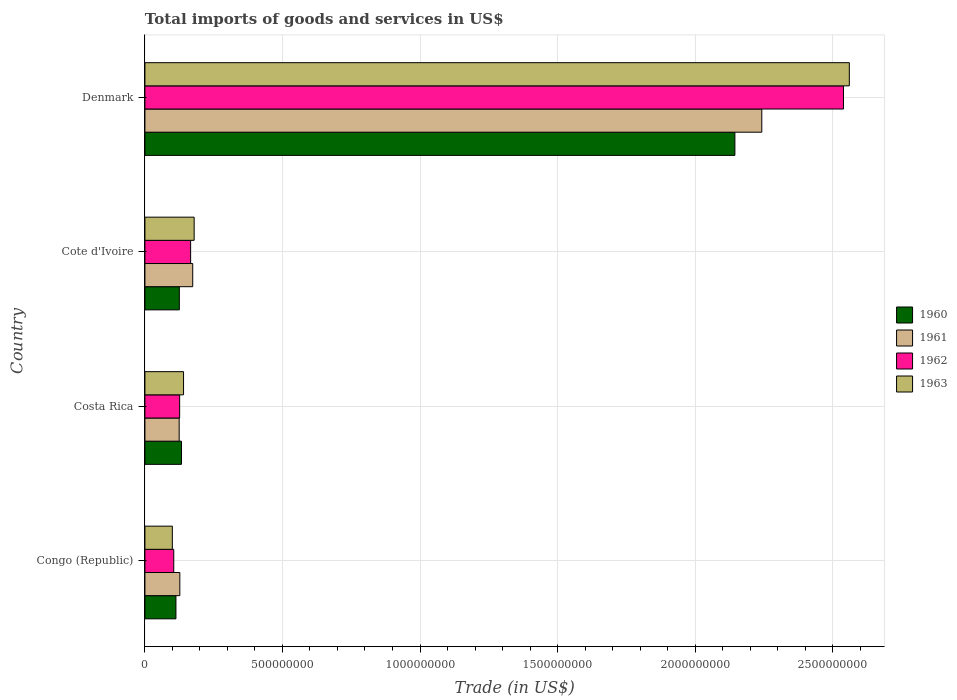How many different coloured bars are there?
Offer a very short reply. 4. How many bars are there on the 4th tick from the top?
Provide a short and direct response. 4. How many bars are there on the 3rd tick from the bottom?
Provide a succinct answer. 4. What is the label of the 2nd group of bars from the top?
Provide a short and direct response. Cote d'Ivoire. In how many cases, is the number of bars for a given country not equal to the number of legend labels?
Give a very brief answer. 0. What is the total imports of goods and services in 1962 in Costa Rica?
Your answer should be very brief. 1.26e+08. Across all countries, what is the maximum total imports of goods and services in 1963?
Your answer should be compact. 2.56e+09. Across all countries, what is the minimum total imports of goods and services in 1960?
Make the answer very short. 1.13e+08. In which country was the total imports of goods and services in 1962 minimum?
Your answer should be compact. Congo (Republic). What is the total total imports of goods and services in 1960 in the graph?
Provide a short and direct response. 2.52e+09. What is the difference between the total imports of goods and services in 1961 in Costa Rica and that in Denmark?
Provide a short and direct response. -2.12e+09. What is the difference between the total imports of goods and services in 1963 in Cote d'Ivoire and the total imports of goods and services in 1960 in Denmark?
Offer a terse response. -1.97e+09. What is the average total imports of goods and services in 1962 per country?
Give a very brief answer. 7.34e+08. What is the difference between the total imports of goods and services in 1963 and total imports of goods and services in 1962 in Congo (Republic)?
Make the answer very short. -5.20e+06. What is the ratio of the total imports of goods and services in 1961 in Costa Rica to that in Denmark?
Your response must be concise. 0.06. Is the total imports of goods and services in 1961 in Costa Rica less than that in Cote d'Ivoire?
Offer a terse response. Yes. Is the difference between the total imports of goods and services in 1963 in Costa Rica and Cote d'Ivoire greater than the difference between the total imports of goods and services in 1962 in Costa Rica and Cote d'Ivoire?
Offer a terse response. Yes. What is the difference between the highest and the second highest total imports of goods and services in 1960?
Make the answer very short. 2.01e+09. What is the difference between the highest and the lowest total imports of goods and services in 1963?
Provide a succinct answer. 2.46e+09. What does the 3rd bar from the top in Denmark represents?
Your answer should be very brief. 1961. What does the 4th bar from the bottom in Cote d'Ivoire represents?
Keep it short and to the point. 1963. How many countries are there in the graph?
Offer a very short reply. 4. What is the difference between two consecutive major ticks on the X-axis?
Offer a very short reply. 5.00e+08. Are the values on the major ticks of X-axis written in scientific E-notation?
Make the answer very short. No. Where does the legend appear in the graph?
Ensure brevity in your answer.  Center right. What is the title of the graph?
Provide a short and direct response. Total imports of goods and services in US$. What is the label or title of the X-axis?
Provide a succinct answer. Trade (in US$). What is the Trade (in US$) in 1960 in Congo (Republic)?
Offer a terse response. 1.13e+08. What is the Trade (in US$) of 1961 in Congo (Republic)?
Provide a short and direct response. 1.27e+08. What is the Trade (in US$) in 1962 in Congo (Republic)?
Offer a terse response. 1.05e+08. What is the Trade (in US$) in 1963 in Congo (Republic)?
Your response must be concise. 9.96e+07. What is the Trade (in US$) of 1960 in Costa Rica?
Provide a succinct answer. 1.33e+08. What is the Trade (in US$) in 1961 in Costa Rica?
Ensure brevity in your answer.  1.25e+08. What is the Trade (in US$) in 1962 in Costa Rica?
Provide a short and direct response. 1.26e+08. What is the Trade (in US$) of 1963 in Costa Rica?
Provide a succinct answer. 1.40e+08. What is the Trade (in US$) in 1960 in Cote d'Ivoire?
Provide a short and direct response. 1.25e+08. What is the Trade (in US$) in 1961 in Cote d'Ivoire?
Ensure brevity in your answer.  1.74e+08. What is the Trade (in US$) in 1962 in Cote d'Ivoire?
Your answer should be compact. 1.66e+08. What is the Trade (in US$) of 1963 in Cote d'Ivoire?
Your answer should be very brief. 1.79e+08. What is the Trade (in US$) in 1960 in Denmark?
Offer a very short reply. 2.14e+09. What is the Trade (in US$) of 1961 in Denmark?
Give a very brief answer. 2.24e+09. What is the Trade (in US$) of 1962 in Denmark?
Offer a very short reply. 2.54e+09. What is the Trade (in US$) of 1963 in Denmark?
Make the answer very short. 2.56e+09. Across all countries, what is the maximum Trade (in US$) in 1960?
Your response must be concise. 2.14e+09. Across all countries, what is the maximum Trade (in US$) of 1961?
Keep it short and to the point. 2.24e+09. Across all countries, what is the maximum Trade (in US$) in 1962?
Provide a succinct answer. 2.54e+09. Across all countries, what is the maximum Trade (in US$) in 1963?
Provide a short and direct response. 2.56e+09. Across all countries, what is the minimum Trade (in US$) of 1960?
Give a very brief answer. 1.13e+08. Across all countries, what is the minimum Trade (in US$) of 1961?
Your answer should be very brief. 1.25e+08. Across all countries, what is the minimum Trade (in US$) in 1962?
Your response must be concise. 1.05e+08. Across all countries, what is the minimum Trade (in US$) of 1963?
Provide a short and direct response. 9.96e+07. What is the total Trade (in US$) in 1960 in the graph?
Offer a very short reply. 2.52e+09. What is the total Trade (in US$) of 1961 in the graph?
Your answer should be very brief. 2.67e+09. What is the total Trade (in US$) in 1962 in the graph?
Make the answer very short. 2.94e+09. What is the total Trade (in US$) in 1963 in the graph?
Provide a succinct answer. 2.98e+09. What is the difference between the Trade (in US$) in 1960 in Congo (Republic) and that in Costa Rica?
Your answer should be compact. -2.01e+07. What is the difference between the Trade (in US$) in 1961 in Congo (Republic) and that in Costa Rica?
Provide a succinct answer. 2.36e+06. What is the difference between the Trade (in US$) of 1962 in Congo (Republic) and that in Costa Rica?
Make the answer very short. -2.14e+07. What is the difference between the Trade (in US$) in 1963 in Congo (Republic) and that in Costa Rica?
Provide a short and direct response. -4.08e+07. What is the difference between the Trade (in US$) in 1960 in Congo (Republic) and that in Cote d'Ivoire?
Keep it short and to the point. -1.23e+07. What is the difference between the Trade (in US$) of 1961 in Congo (Republic) and that in Cote d'Ivoire?
Give a very brief answer. -4.69e+07. What is the difference between the Trade (in US$) of 1962 in Congo (Republic) and that in Cote d'Ivoire?
Offer a terse response. -6.13e+07. What is the difference between the Trade (in US$) of 1963 in Congo (Republic) and that in Cote d'Ivoire?
Your answer should be very brief. -7.94e+07. What is the difference between the Trade (in US$) in 1960 in Congo (Republic) and that in Denmark?
Offer a very short reply. -2.03e+09. What is the difference between the Trade (in US$) of 1961 in Congo (Republic) and that in Denmark?
Keep it short and to the point. -2.12e+09. What is the difference between the Trade (in US$) of 1962 in Congo (Republic) and that in Denmark?
Your answer should be compact. -2.43e+09. What is the difference between the Trade (in US$) in 1963 in Congo (Republic) and that in Denmark?
Your response must be concise. -2.46e+09. What is the difference between the Trade (in US$) of 1960 in Costa Rica and that in Cote d'Ivoire?
Provide a short and direct response. 7.75e+06. What is the difference between the Trade (in US$) of 1961 in Costa Rica and that in Cote d'Ivoire?
Offer a terse response. -4.92e+07. What is the difference between the Trade (in US$) of 1962 in Costa Rica and that in Cote d'Ivoire?
Your response must be concise. -3.99e+07. What is the difference between the Trade (in US$) in 1963 in Costa Rica and that in Cote d'Ivoire?
Give a very brief answer. -3.86e+07. What is the difference between the Trade (in US$) in 1960 in Costa Rica and that in Denmark?
Your answer should be compact. -2.01e+09. What is the difference between the Trade (in US$) of 1961 in Costa Rica and that in Denmark?
Your answer should be compact. -2.12e+09. What is the difference between the Trade (in US$) in 1962 in Costa Rica and that in Denmark?
Your response must be concise. -2.41e+09. What is the difference between the Trade (in US$) of 1963 in Costa Rica and that in Denmark?
Your response must be concise. -2.42e+09. What is the difference between the Trade (in US$) in 1960 in Cote d'Ivoire and that in Denmark?
Your answer should be compact. -2.02e+09. What is the difference between the Trade (in US$) of 1961 in Cote d'Ivoire and that in Denmark?
Offer a terse response. -2.07e+09. What is the difference between the Trade (in US$) in 1962 in Cote d'Ivoire and that in Denmark?
Offer a terse response. -2.37e+09. What is the difference between the Trade (in US$) in 1963 in Cote d'Ivoire and that in Denmark?
Your answer should be very brief. -2.38e+09. What is the difference between the Trade (in US$) of 1960 in Congo (Republic) and the Trade (in US$) of 1961 in Costa Rica?
Provide a succinct answer. -1.18e+07. What is the difference between the Trade (in US$) in 1960 in Congo (Republic) and the Trade (in US$) in 1962 in Costa Rica?
Offer a terse response. -1.35e+07. What is the difference between the Trade (in US$) of 1960 in Congo (Republic) and the Trade (in US$) of 1963 in Costa Rica?
Your answer should be very brief. -2.77e+07. What is the difference between the Trade (in US$) of 1961 in Congo (Republic) and the Trade (in US$) of 1962 in Costa Rica?
Give a very brief answer. 6.55e+05. What is the difference between the Trade (in US$) in 1961 in Congo (Republic) and the Trade (in US$) in 1963 in Costa Rica?
Offer a very short reply. -1.35e+07. What is the difference between the Trade (in US$) of 1962 in Congo (Republic) and the Trade (in US$) of 1963 in Costa Rica?
Offer a terse response. -3.56e+07. What is the difference between the Trade (in US$) of 1960 in Congo (Republic) and the Trade (in US$) of 1961 in Cote d'Ivoire?
Provide a succinct answer. -6.10e+07. What is the difference between the Trade (in US$) in 1960 in Congo (Republic) and the Trade (in US$) in 1962 in Cote d'Ivoire?
Your answer should be compact. -5.34e+07. What is the difference between the Trade (in US$) of 1960 in Congo (Republic) and the Trade (in US$) of 1963 in Cote d'Ivoire?
Keep it short and to the point. -6.62e+07. What is the difference between the Trade (in US$) in 1961 in Congo (Republic) and the Trade (in US$) in 1962 in Cote d'Ivoire?
Give a very brief answer. -3.92e+07. What is the difference between the Trade (in US$) of 1961 in Congo (Republic) and the Trade (in US$) of 1963 in Cote d'Ivoire?
Your answer should be compact. -5.21e+07. What is the difference between the Trade (in US$) in 1962 in Congo (Republic) and the Trade (in US$) in 1963 in Cote d'Ivoire?
Offer a very short reply. -7.42e+07. What is the difference between the Trade (in US$) in 1960 in Congo (Republic) and the Trade (in US$) in 1961 in Denmark?
Provide a succinct answer. -2.13e+09. What is the difference between the Trade (in US$) of 1960 in Congo (Republic) and the Trade (in US$) of 1962 in Denmark?
Offer a very short reply. -2.43e+09. What is the difference between the Trade (in US$) in 1960 in Congo (Republic) and the Trade (in US$) in 1963 in Denmark?
Your answer should be compact. -2.45e+09. What is the difference between the Trade (in US$) of 1961 in Congo (Republic) and the Trade (in US$) of 1962 in Denmark?
Provide a succinct answer. -2.41e+09. What is the difference between the Trade (in US$) of 1961 in Congo (Republic) and the Trade (in US$) of 1963 in Denmark?
Make the answer very short. -2.43e+09. What is the difference between the Trade (in US$) in 1962 in Congo (Republic) and the Trade (in US$) in 1963 in Denmark?
Your answer should be compact. -2.46e+09. What is the difference between the Trade (in US$) in 1960 in Costa Rica and the Trade (in US$) in 1961 in Cote d'Ivoire?
Provide a succinct answer. -4.09e+07. What is the difference between the Trade (in US$) of 1960 in Costa Rica and the Trade (in US$) of 1962 in Cote d'Ivoire?
Keep it short and to the point. -3.33e+07. What is the difference between the Trade (in US$) in 1960 in Costa Rica and the Trade (in US$) in 1963 in Cote d'Ivoire?
Offer a terse response. -4.61e+07. What is the difference between the Trade (in US$) in 1961 in Costa Rica and the Trade (in US$) in 1962 in Cote d'Ivoire?
Make the answer very short. -4.16e+07. What is the difference between the Trade (in US$) in 1961 in Costa Rica and the Trade (in US$) in 1963 in Cote d'Ivoire?
Offer a terse response. -5.45e+07. What is the difference between the Trade (in US$) in 1962 in Costa Rica and the Trade (in US$) in 1963 in Cote d'Ivoire?
Provide a short and direct response. -5.28e+07. What is the difference between the Trade (in US$) in 1960 in Costa Rica and the Trade (in US$) in 1961 in Denmark?
Make the answer very short. -2.11e+09. What is the difference between the Trade (in US$) of 1960 in Costa Rica and the Trade (in US$) of 1962 in Denmark?
Provide a short and direct response. -2.41e+09. What is the difference between the Trade (in US$) of 1960 in Costa Rica and the Trade (in US$) of 1963 in Denmark?
Your response must be concise. -2.43e+09. What is the difference between the Trade (in US$) in 1961 in Costa Rica and the Trade (in US$) in 1962 in Denmark?
Offer a very short reply. -2.42e+09. What is the difference between the Trade (in US$) of 1961 in Costa Rica and the Trade (in US$) of 1963 in Denmark?
Your answer should be compact. -2.44e+09. What is the difference between the Trade (in US$) of 1962 in Costa Rica and the Trade (in US$) of 1963 in Denmark?
Offer a terse response. -2.43e+09. What is the difference between the Trade (in US$) in 1960 in Cote d'Ivoire and the Trade (in US$) in 1961 in Denmark?
Your answer should be very brief. -2.12e+09. What is the difference between the Trade (in US$) in 1960 in Cote d'Ivoire and the Trade (in US$) in 1962 in Denmark?
Your answer should be very brief. -2.41e+09. What is the difference between the Trade (in US$) of 1960 in Cote d'Ivoire and the Trade (in US$) of 1963 in Denmark?
Offer a very short reply. -2.44e+09. What is the difference between the Trade (in US$) of 1961 in Cote d'Ivoire and the Trade (in US$) of 1962 in Denmark?
Give a very brief answer. -2.37e+09. What is the difference between the Trade (in US$) of 1961 in Cote d'Ivoire and the Trade (in US$) of 1963 in Denmark?
Provide a short and direct response. -2.39e+09. What is the difference between the Trade (in US$) of 1962 in Cote d'Ivoire and the Trade (in US$) of 1963 in Denmark?
Your response must be concise. -2.39e+09. What is the average Trade (in US$) in 1960 per country?
Keep it short and to the point. 6.29e+08. What is the average Trade (in US$) in 1961 per country?
Offer a very short reply. 6.67e+08. What is the average Trade (in US$) in 1962 per country?
Keep it short and to the point. 7.34e+08. What is the average Trade (in US$) in 1963 per country?
Your response must be concise. 7.45e+08. What is the difference between the Trade (in US$) of 1960 and Trade (in US$) of 1961 in Congo (Republic)?
Offer a terse response. -1.41e+07. What is the difference between the Trade (in US$) of 1960 and Trade (in US$) of 1962 in Congo (Republic)?
Your response must be concise. 7.94e+06. What is the difference between the Trade (in US$) of 1960 and Trade (in US$) of 1963 in Congo (Republic)?
Ensure brevity in your answer.  1.31e+07. What is the difference between the Trade (in US$) in 1961 and Trade (in US$) in 1962 in Congo (Republic)?
Your answer should be compact. 2.21e+07. What is the difference between the Trade (in US$) of 1961 and Trade (in US$) of 1963 in Congo (Republic)?
Your answer should be very brief. 2.73e+07. What is the difference between the Trade (in US$) of 1962 and Trade (in US$) of 1963 in Congo (Republic)?
Ensure brevity in your answer.  5.20e+06. What is the difference between the Trade (in US$) in 1960 and Trade (in US$) in 1961 in Costa Rica?
Make the answer very short. 8.32e+06. What is the difference between the Trade (in US$) of 1960 and Trade (in US$) of 1962 in Costa Rica?
Provide a short and direct response. 6.62e+06. What is the difference between the Trade (in US$) of 1960 and Trade (in US$) of 1963 in Costa Rica?
Make the answer very short. -7.58e+06. What is the difference between the Trade (in US$) of 1961 and Trade (in US$) of 1962 in Costa Rica?
Your answer should be very brief. -1.70e+06. What is the difference between the Trade (in US$) of 1961 and Trade (in US$) of 1963 in Costa Rica?
Your response must be concise. -1.59e+07. What is the difference between the Trade (in US$) in 1962 and Trade (in US$) in 1963 in Costa Rica?
Provide a short and direct response. -1.42e+07. What is the difference between the Trade (in US$) of 1960 and Trade (in US$) of 1961 in Cote d'Ivoire?
Ensure brevity in your answer.  -4.86e+07. What is the difference between the Trade (in US$) in 1960 and Trade (in US$) in 1962 in Cote d'Ivoire?
Offer a very short reply. -4.10e+07. What is the difference between the Trade (in US$) in 1960 and Trade (in US$) in 1963 in Cote d'Ivoire?
Make the answer very short. -5.39e+07. What is the difference between the Trade (in US$) of 1961 and Trade (in US$) of 1962 in Cote d'Ivoire?
Provide a short and direct response. 7.61e+06. What is the difference between the Trade (in US$) in 1961 and Trade (in US$) in 1963 in Cote d'Ivoire?
Make the answer very short. -5.25e+06. What is the difference between the Trade (in US$) of 1962 and Trade (in US$) of 1963 in Cote d'Ivoire?
Provide a succinct answer. -1.29e+07. What is the difference between the Trade (in US$) of 1960 and Trade (in US$) of 1961 in Denmark?
Keep it short and to the point. -9.78e+07. What is the difference between the Trade (in US$) of 1960 and Trade (in US$) of 1962 in Denmark?
Your answer should be compact. -3.95e+08. What is the difference between the Trade (in US$) of 1960 and Trade (in US$) of 1963 in Denmark?
Your response must be concise. -4.16e+08. What is the difference between the Trade (in US$) of 1961 and Trade (in US$) of 1962 in Denmark?
Offer a terse response. -2.97e+08. What is the difference between the Trade (in US$) of 1961 and Trade (in US$) of 1963 in Denmark?
Keep it short and to the point. -3.18e+08. What is the difference between the Trade (in US$) in 1962 and Trade (in US$) in 1963 in Denmark?
Ensure brevity in your answer.  -2.12e+07. What is the ratio of the Trade (in US$) in 1960 in Congo (Republic) to that in Costa Rica?
Your response must be concise. 0.85. What is the ratio of the Trade (in US$) in 1961 in Congo (Republic) to that in Costa Rica?
Ensure brevity in your answer.  1.02. What is the ratio of the Trade (in US$) of 1962 in Congo (Republic) to that in Costa Rica?
Offer a terse response. 0.83. What is the ratio of the Trade (in US$) of 1963 in Congo (Republic) to that in Costa Rica?
Your answer should be very brief. 0.71. What is the ratio of the Trade (in US$) of 1960 in Congo (Republic) to that in Cote d'Ivoire?
Your answer should be very brief. 0.9. What is the ratio of the Trade (in US$) of 1961 in Congo (Republic) to that in Cote d'Ivoire?
Offer a very short reply. 0.73. What is the ratio of the Trade (in US$) of 1962 in Congo (Republic) to that in Cote d'Ivoire?
Your answer should be compact. 0.63. What is the ratio of the Trade (in US$) of 1963 in Congo (Republic) to that in Cote d'Ivoire?
Offer a very short reply. 0.56. What is the ratio of the Trade (in US$) in 1960 in Congo (Republic) to that in Denmark?
Provide a short and direct response. 0.05. What is the ratio of the Trade (in US$) in 1961 in Congo (Republic) to that in Denmark?
Offer a terse response. 0.06. What is the ratio of the Trade (in US$) in 1962 in Congo (Republic) to that in Denmark?
Keep it short and to the point. 0.04. What is the ratio of the Trade (in US$) of 1963 in Congo (Republic) to that in Denmark?
Your answer should be very brief. 0.04. What is the ratio of the Trade (in US$) in 1960 in Costa Rica to that in Cote d'Ivoire?
Keep it short and to the point. 1.06. What is the ratio of the Trade (in US$) of 1961 in Costa Rica to that in Cote d'Ivoire?
Provide a short and direct response. 0.72. What is the ratio of the Trade (in US$) of 1962 in Costa Rica to that in Cote d'Ivoire?
Your answer should be very brief. 0.76. What is the ratio of the Trade (in US$) of 1963 in Costa Rica to that in Cote d'Ivoire?
Give a very brief answer. 0.78. What is the ratio of the Trade (in US$) in 1960 in Costa Rica to that in Denmark?
Provide a short and direct response. 0.06. What is the ratio of the Trade (in US$) in 1961 in Costa Rica to that in Denmark?
Ensure brevity in your answer.  0.06. What is the ratio of the Trade (in US$) in 1962 in Costa Rica to that in Denmark?
Offer a very short reply. 0.05. What is the ratio of the Trade (in US$) of 1963 in Costa Rica to that in Denmark?
Offer a very short reply. 0.05. What is the ratio of the Trade (in US$) of 1960 in Cote d'Ivoire to that in Denmark?
Offer a terse response. 0.06. What is the ratio of the Trade (in US$) of 1961 in Cote d'Ivoire to that in Denmark?
Ensure brevity in your answer.  0.08. What is the ratio of the Trade (in US$) of 1962 in Cote d'Ivoire to that in Denmark?
Your answer should be compact. 0.07. What is the ratio of the Trade (in US$) in 1963 in Cote d'Ivoire to that in Denmark?
Ensure brevity in your answer.  0.07. What is the difference between the highest and the second highest Trade (in US$) in 1960?
Provide a succinct answer. 2.01e+09. What is the difference between the highest and the second highest Trade (in US$) in 1961?
Make the answer very short. 2.07e+09. What is the difference between the highest and the second highest Trade (in US$) of 1962?
Ensure brevity in your answer.  2.37e+09. What is the difference between the highest and the second highest Trade (in US$) in 1963?
Ensure brevity in your answer.  2.38e+09. What is the difference between the highest and the lowest Trade (in US$) in 1960?
Make the answer very short. 2.03e+09. What is the difference between the highest and the lowest Trade (in US$) in 1961?
Give a very brief answer. 2.12e+09. What is the difference between the highest and the lowest Trade (in US$) of 1962?
Keep it short and to the point. 2.43e+09. What is the difference between the highest and the lowest Trade (in US$) in 1963?
Keep it short and to the point. 2.46e+09. 